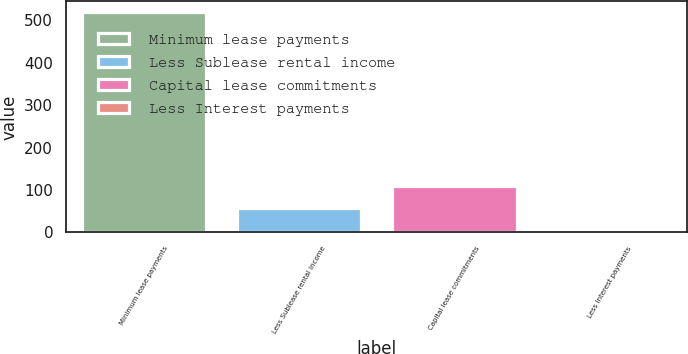Convert chart. <chart><loc_0><loc_0><loc_500><loc_500><bar_chart><fcel>Minimum lease payments<fcel>Less Sublease rental income<fcel>Capital lease commitments<fcel>Less Interest payments<nl><fcel>519<fcel>58.2<fcel>109.4<fcel>7<nl></chart> 